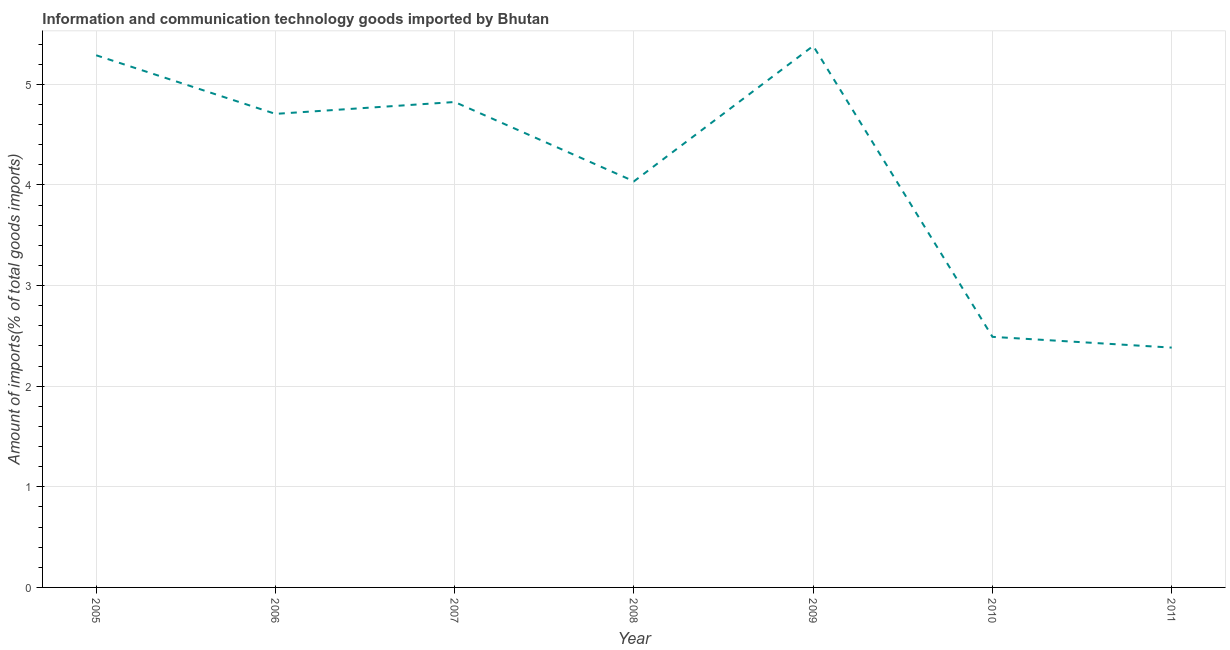What is the amount of ict goods imports in 2007?
Ensure brevity in your answer.  4.82. Across all years, what is the maximum amount of ict goods imports?
Make the answer very short. 5.38. Across all years, what is the minimum amount of ict goods imports?
Offer a very short reply. 2.38. In which year was the amount of ict goods imports minimum?
Offer a terse response. 2011. What is the sum of the amount of ict goods imports?
Provide a succinct answer. 29.11. What is the difference between the amount of ict goods imports in 2006 and 2008?
Your response must be concise. 0.67. What is the average amount of ict goods imports per year?
Keep it short and to the point. 4.16. What is the median amount of ict goods imports?
Your response must be concise. 4.71. In how many years, is the amount of ict goods imports greater than 0.6000000000000001 %?
Your answer should be compact. 7. Do a majority of the years between 2009 and 2006 (inclusive) have amount of ict goods imports greater than 4.2 %?
Ensure brevity in your answer.  Yes. What is the ratio of the amount of ict goods imports in 2010 to that in 2011?
Offer a very short reply. 1.04. What is the difference between the highest and the second highest amount of ict goods imports?
Ensure brevity in your answer.  0.09. What is the difference between the highest and the lowest amount of ict goods imports?
Provide a succinct answer. 3. In how many years, is the amount of ict goods imports greater than the average amount of ict goods imports taken over all years?
Provide a short and direct response. 4. Does the amount of ict goods imports monotonically increase over the years?
Provide a short and direct response. No. How many lines are there?
Provide a short and direct response. 1. How many years are there in the graph?
Offer a very short reply. 7. Are the values on the major ticks of Y-axis written in scientific E-notation?
Keep it short and to the point. No. Does the graph contain grids?
Your answer should be compact. Yes. What is the title of the graph?
Provide a short and direct response. Information and communication technology goods imported by Bhutan. What is the label or title of the X-axis?
Provide a succinct answer. Year. What is the label or title of the Y-axis?
Ensure brevity in your answer.  Amount of imports(% of total goods imports). What is the Amount of imports(% of total goods imports) in 2005?
Give a very brief answer. 5.29. What is the Amount of imports(% of total goods imports) in 2006?
Offer a very short reply. 4.71. What is the Amount of imports(% of total goods imports) of 2007?
Provide a short and direct response. 4.82. What is the Amount of imports(% of total goods imports) of 2008?
Provide a short and direct response. 4.04. What is the Amount of imports(% of total goods imports) in 2009?
Give a very brief answer. 5.38. What is the Amount of imports(% of total goods imports) in 2010?
Make the answer very short. 2.49. What is the Amount of imports(% of total goods imports) of 2011?
Give a very brief answer. 2.38. What is the difference between the Amount of imports(% of total goods imports) in 2005 and 2006?
Give a very brief answer. 0.58. What is the difference between the Amount of imports(% of total goods imports) in 2005 and 2007?
Make the answer very short. 0.46. What is the difference between the Amount of imports(% of total goods imports) in 2005 and 2008?
Make the answer very short. 1.25. What is the difference between the Amount of imports(% of total goods imports) in 2005 and 2009?
Ensure brevity in your answer.  -0.09. What is the difference between the Amount of imports(% of total goods imports) in 2005 and 2010?
Make the answer very short. 2.8. What is the difference between the Amount of imports(% of total goods imports) in 2005 and 2011?
Your answer should be very brief. 2.91. What is the difference between the Amount of imports(% of total goods imports) in 2006 and 2007?
Ensure brevity in your answer.  -0.12. What is the difference between the Amount of imports(% of total goods imports) in 2006 and 2008?
Provide a succinct answer. 0.67. What is the difference between the Amount of imports(% of total goods imports) in 2006 and 2009?
Provide a short and direct response. -0.68. What is the difference between the Amount of imports(% of total goods imports) in 2006 and 2010?
Your answer should be very brief. 2.22. What is the difference between the Amount of imports(% of total goods imports) in 2006 and 2011?
Offer a very short reply. 2.32. What is the difference between the Amount of imports(% of total goods imports) in 2007 and 2008?
Make the answer very short. 0.79. What is the difference between the Amount of imports(% of total goods imports) in 2007 and 2009?
Provide a short and direct response. -0.56. What is the difference between the Amount of imports(% of total goods imports) in 2007 and 2010?
Give a very brief answer. 2.33. What is the difference between the Amount of imports(% of total goods imports) in 2007 and 2011?
Ensure brevity in your answer.  2.44. What is the difference between the Amount of imports(% of total goods imports) in 2008 and 2009?
Provide a short and direct response. -1.35. What is the difference between the Amount of imports(% of total goods imports) in 2008 and 2010?
Your answer should be very brief. 1.55. What is the difference between the Amount of imports(% of total goods imports) in 2008 and 2011?
Your response must be concise. 1.65. What is the difference between the Amount of imports(% of total goods imports) in 2009 and 2010?
Your answer should be compact. 2.89. What is the difference between the Amount of imports(% of total goods imports) in 2009 and 2011?
Offer a terse response. 3. What is the difference between the Amount of imports(% of total goods imports) in 2010 and 2011?
Keep it short and to the point. 0.11. What is the ratio of the Amount of imports(% of total goods imports) in 2005 to that in 2006?
Provide a short and direct response. 1.12. What is the ratio of the Amount of imports(% of total goods imports) in 2005 to that in 2007?
Your response must be concise. 1.1. What is the ratio of the Amount of imports(% of total goods imports) in 2005 to that in 2008?
Keep it short and to the point. 1.31. What is the ratio of the Amount of imports(% of total goods imports) in 2005 to that in 2010?
Ensure brevity in your answer.  2.12. What is the ratio of the Amount of imports(% of total goods imports) in 2005 to that in 2011?
Your response must be concise. 2.22. What is the ratio of the Amount of imports(% of total goods imports) in 2006 to that in 2007?
Ensure brevity in your answer.  0.98. What is the ratio of the Amount of imports(% of total goods imports) in 2006 to that in 2008?
Keep it short and to the point. 1.17. What is the ratio of the Amount of imports(% of total goods imports) in 2006 to that in 2009?
Your answer should be compact. 0.87. What is the ratio of the Amount of imports(% of total goods imports) in 2006 to that in 2010?
Give a very brief answer. 1.89. What is the ratio of the Amount of imports(% of total goods imports) in 2006 to that in 2011?
Keep it short and to the point. 1.98. What is the ratio of the Amount of imports(% of total goods imports) in 2007 to that in 2008?
Ensure brevity in your answer.  1.2. What is the ratio of the Amount of imports(% of total goods imports) in 2007 to that in 2009?
Your answer should be compact. 0.9. What is the ratio of the Amount of imports(% of total goods imports) in 2007 to that in 2010?
Ensure brevity in your answer.  1.94. What is the ratio of the Amount of imports(% of total goods imports) in 2007 to that in 2011?
Provide a succinct answer. 2.02. What is the ratio of the Amount of imports(% of total goods imports) in 2008 to that in 2010?
Offer a terse response. 1.62. What is the ratio of the Amount of imports(% of total goods imports) in 2008 to that in 2011?
Offer a very short reply. 1.69. What is the ratio of the Amount of imports(% of total goods imports) in 2009 to that in 2010?
Your answer should be very brief. 2.16. What is the ratio of the Amount of imports(% of total goods imports) in 2009 to that in 2011?
Offer a terse response. 2.26. What is the ratio of the Amount of imports(% of total goods imports) in 2010 to that in 2011?
Provide a succinct answer. 1.04. 